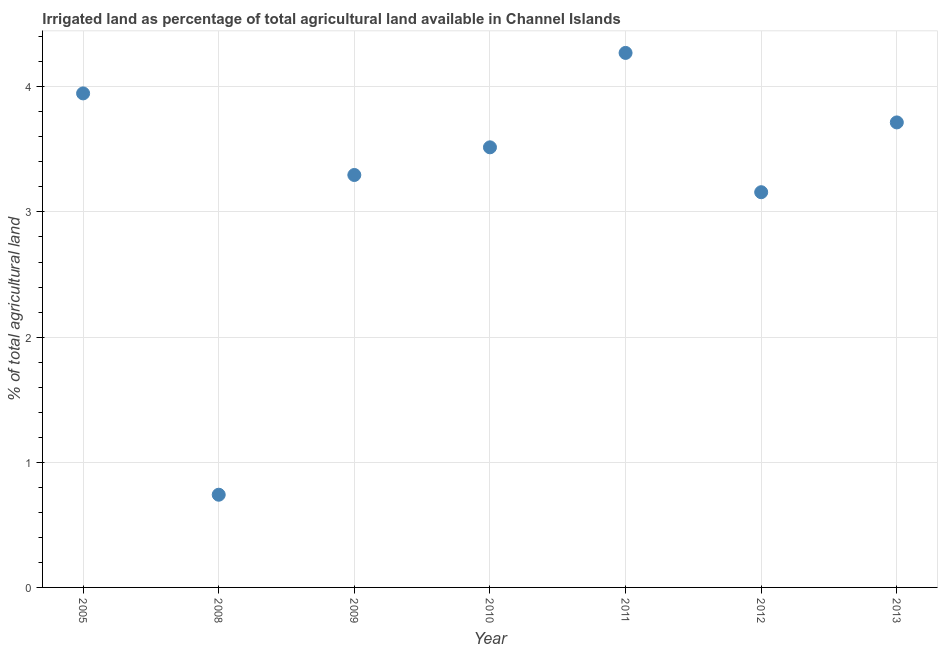What is the percentage of agricultural irrigated land in 2008?
Ensure brevity in your answer.  0.74. Across all years, what is the maximum percentage of agricultural irrigated land?
Make the answer very short. 4.27. Across all years, what is the minimum percentage of agricultural irrigated land?
Your answer should be very brief. 0.74. What is the sum of the percentage of agricultural irrigated land?
Make the answer very short. 22.64. What is the difference between the percentage of agricultural irrigated land in 2008 and 2009?
Provide a short and direct response. -2.55. What is the average percentage of agricultural irrigated land per year?
Make the answer very short. 3.23. What is the median percentage of agricultural irrigated land?
Your answer should be compact. 3.52. What is the ratio of the percentage of agricultural irrigated land in 2005 to that in 2010?
Keep it short and to the point. 1.12. What is the difference between the highest and the second highest percentage of agricultural irrigated land?
Ensure brevity in your answer.  0.32. Is the sum of the percentage of agricultural irrigated land in 2010 and 2013 greater than the maximum percentage of agricultural irrigated land across all years?
Provide a succinct answer. Yes. What is the difference between the highest and the lowest percentage of agricultural irrigated land?
Provide a succinct answer. 3.53. Are the values on the major ticks of Y-axis written in scientific E-notation?
Give a very brief answer. No. What is the title of the graph?
Give a very brief answer. Irrigated land as percentage of total agricultural land available in Channel Islands. What is the label or title of the Y-axis?
Ensure brevity in your answer.  % of total agricultural land. What is the % of total agricultural land in 2005?
Keep it short and to the point. 3.95. What is the % of total agricultural land in 2008?
Your response must be concise. 0.74. What is the % of total agricultural land in 2009?
Make the answer very short. 3.3. What is the % of total agricultural land in 2010?
Keep it short and to the point. 3.52. What is the % of total agricultural land in 2011?
Provide a short and direct response. 4.27. What is the % of total agricultural land in 2012?
Offer a very short reply. 3.16. What is the % of total agricultural land in 2013?
Give a very brief answer. 3.72. What is the difference between the % of total agricultural land in 2005 and 2008?
Offer a very short reply. 3.21. What is the difference between the % of total agricultural land in 2005 and 2009?
Your response must be concise. 0.65. What is the difference between the % of total agricultural land in 2005 and 2010?
Offer a very short reply. 0.43. What is the difference between the % of total agricultural land in 2005 and 2011?
Keep it short and to the point. -0.32. What is the difference between the % of total agricultural land in 2005 and 2012?
Ensure brevity in your answer.  0.79. What is the difference between the % of total agricultural land in 2005 and 2013?
Keep it short and to the point. 0.23. What is the difference between the % of total agricultural land in 2008 and 2009?
Give a very brief answer. -2.55. What is the difference between the % of total agricultural land in 2008 and 2010?
Give a very brief answer. -2.78. What is the difference between the % of total agricultural land in 2008 and 2011?
Provide a short and direct response. -3.53. What is the difference between the % of total agricultural land in 2008 and 2012?
Keep it short and to the point. -2.42. What is the difference between the % of total agricultural land in 2008 and 2013?
Offer a very short reply. -2.97. What is the difference between the % of total agricultural land in 2009 and 2010?
Give a very brief answer. -0.22. What is the difference between the % of total agricultural land in 2009 and 2011?
Provide a succinct answer. -0.98. What is the difference between the % of total agricultural land in 2009 and 2012?
Your answer should be compact. 0.14. What is the difference between the % of total agricultural land in 2009 and 2013?
Provide a short and direct response. -0.42. What is the difference between the % of total agricultural land in 2010 and 2011?
Your answer should be compact. -0.75. What is the difference between the % of total agricultural land in 2010 and 2012?
Your answer should be very brief. 0.36. What is the difference between the % of total agricultural land in 2010 and 2013?
Your answer should be very brief. -0.2. What is the difference between the % of total agricultural land in 2011 and 2012?
Make the answer very short. 1.11. What is the difference between the % of total agricultural land in 2011 and 2013?
Offer a terse response. 0.56. What is the difference between the % of total agricultural land in 2012 and 2013?
Ensure brevity in your answer.  -0.56. What is the ratio of the % of total agricultural land in 2005 to that in 2008?
Provide a short and direct response. 5.33. What is the ratio of the % of total agricultural land in 2005 to that in 2009?
Make the answer very short. 1.2. What is the ratio of the % of total agricultural land in 2005 to that in 2010?
Offer a terse response. 1.12. What is the ratio of the % of total agricultural land in 2005 to that in 2011?
Keep it short and to the point. 0.92. What is the ratio of the % of total agricultural land in 2005 to that in 2013?
Keep it short and to the point. 1.06. What is the ratio of the % of total agricultural land in 2008 to that in 2009?
Your response must be concise. 0.23. What is the ratio of the % of total agricultural land in 2008 to that in 2010?
Give a very brief answer. 0.21. What is the ratio of the % of total agricultural land in 2008 to that in 2011?
Make the answer very short. 0.17. What is the ratio of the % of total agricultural land in 2008 to that in 2012?
Ensure brevity in your answer.  0.23. What is the ratio of the % of total agricultural land in 2008 to that in 2013?
Keep it short and to the point. 0.2. What is the ratio of the % of total agricultural land in 2009 to that in 2010?
Give a very brief answer. 0.94. What is the ratio of the % of total agricultural land in 2009 to that in 2011?
Your answer should be compact. 0.77. What is the ratio of the % of total agricultural land in 2009 to that in 2012?
Offer a terse response. 1.04. What is the ratio of the % of total agricultural land in 2009 to that in 2013?
Your answer should be compact. 0.89. What is the ratio of the % of total agricultural land in 2010 to that in 2011?
Provide a short and direct response. 0.82. What is the ratio of the % of total agricultural land in 2010 to that in 2012?
Keep it short and to the point. 1.11. What is the ratio of the % of total agricultural land in 2010 to that in 2013?
Your answer should be compact. 0.95. What is the ratio of the % of total agricultural land in 2011 to that in 2012?
Ensure brevity in your answer.  1.35. What is the ratio of the % of total agricultural land in 2011 to that in 2013?
Provide a short and direct response. 1.15. What is the ratio of the % of total agricultural land in 2012 to that in 2013?
Keep it short and to the point. 0.85. 